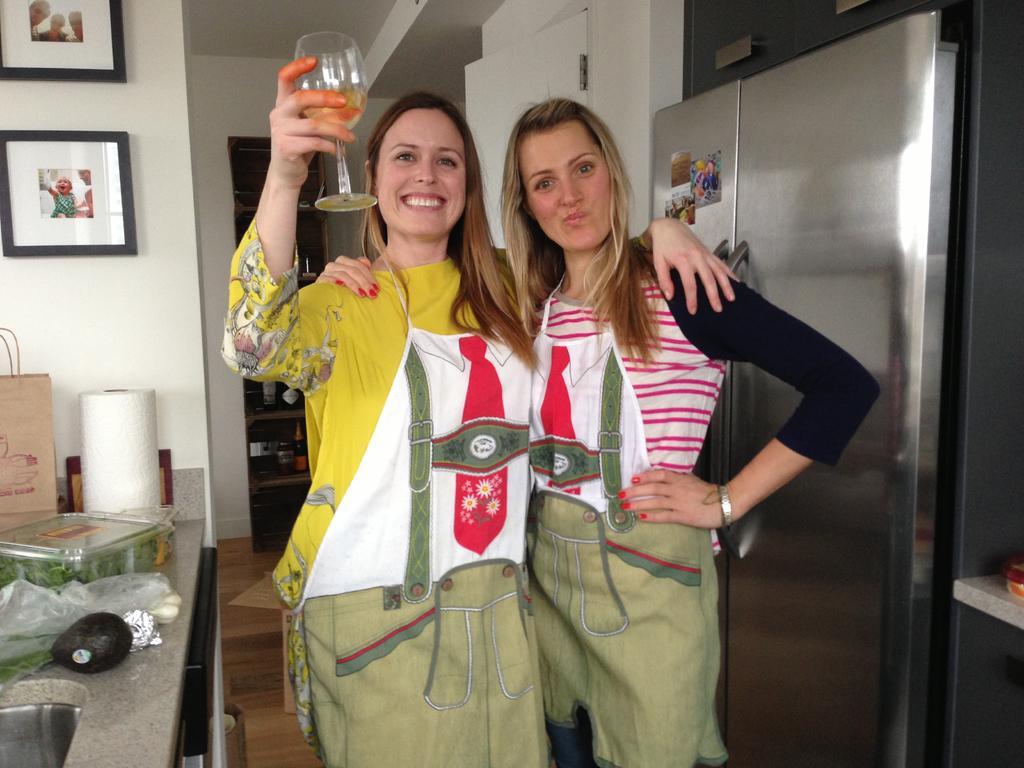In one or two sentences, can you explain what this image depicts? In this picture we can see two women standing and smiling where a woman holding a glass with her hand and in the background we can see a refrigerator, frames, bag and some objects. 